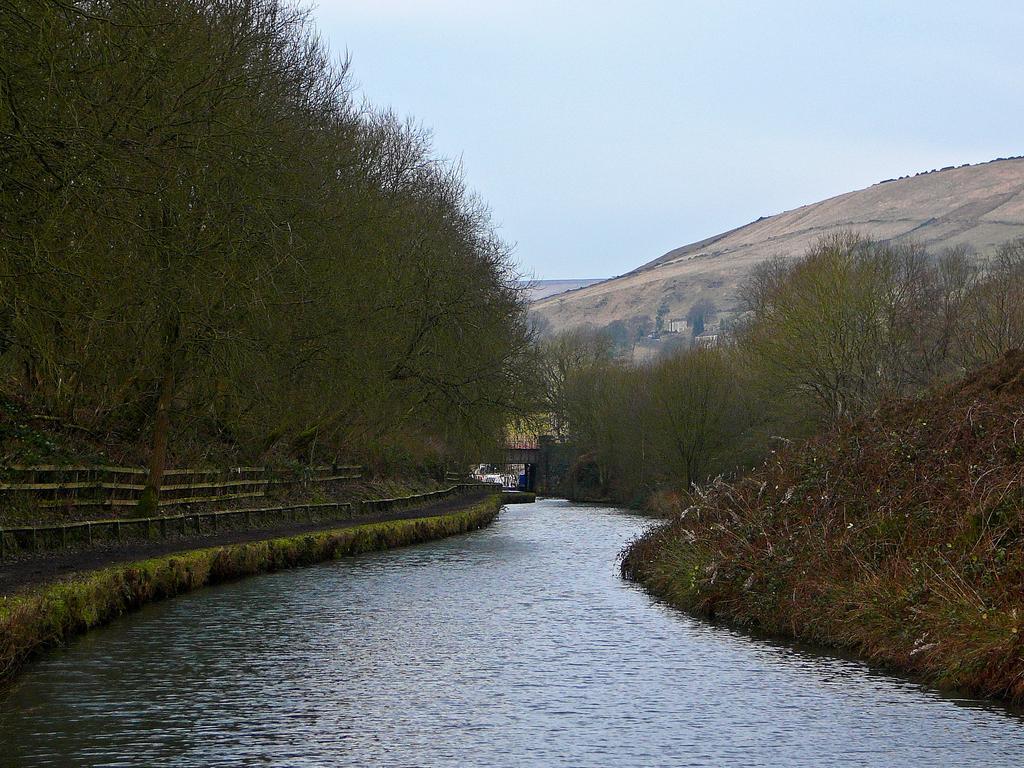How would you summarize this image in a sentence or two? There is water. On the left side there are trees and railings. On the right side there are trees and plants. In the back there are hills, bridge and sky. 